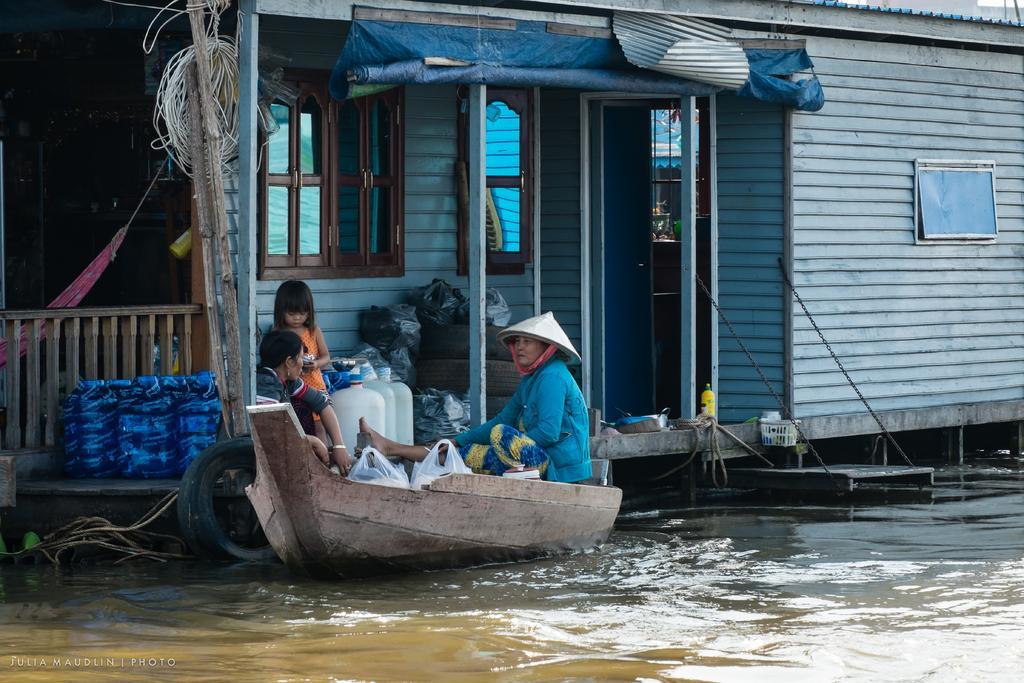In one or two sentences, can you explain what this image depicts? In this picture there are two women sitting in the small boat. In the front bottom side there is a small canal water. Behind we can see the shed house with glass window and doors. 